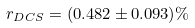Convert formula to latex. <formula><loc_0><loc_0><loc_500><loc_500>r _ { D C S } = ( 0 . 4 8 2 \pm 0 . 0 9 3 ) \%</formula> 